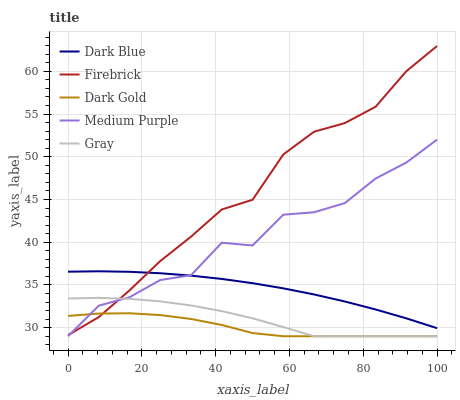Does Dark Gold have the minimum area under the curve?
Answer yes or no. Yes. Does Firebrick have the maximum area under the curve?
Answer yes or no. Yes. Does Dark Blue have the minimum area under the curve?
Answer yes or no. No. Does Dark Blue have the maximum area under the curve?
Answer yes or no. No. Is Dark Blue the smoothest?
Answer yes or no. Yes. Is Medium Purple the roughest?
Answer yes or no. Yes. Is Firebrick the smoothest?
Answer yes or no. No. Is Firebrick the roughest?
Answer yes or no. No. Does Medium Purple have the lowest value?
Answer yes or no. Yes. Does Firebrick have the lowest value?
Answer yes or no. No. Does Firebrick have the highest value?
Answer yes or no. Yes. Does Dark Blue have the highest value?
Answer yes or no. No. Is Dark Gold less than Dark Blue?
Answer yes or no. Yes. Is Dark Blue greater than Gray?
Answer yes or no. Yes. Does Dark Blue intersect Firebrick?
Answer yes or no. Yes. Is Dark Blue less than Firebrick?
Answer yes or no. No. Is Dark Blue greater than Firebrick?
Answer yes or no. No. Does Dark Gold intersect Dark Blue?
Answer yes or no. No. 